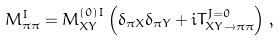<formula> <loc_0><loc_0><loc_500><loc_500>M ^ { I } _ { \pi \pi } = M ^ { ( 0 ) I } _ { X Y } \left ( \delta _ { \pi X } \delta _ { \pi Y } + i T ^ { J = 0 } _ { X Y \to \pi \pi } \right ) \, ,</formula> 